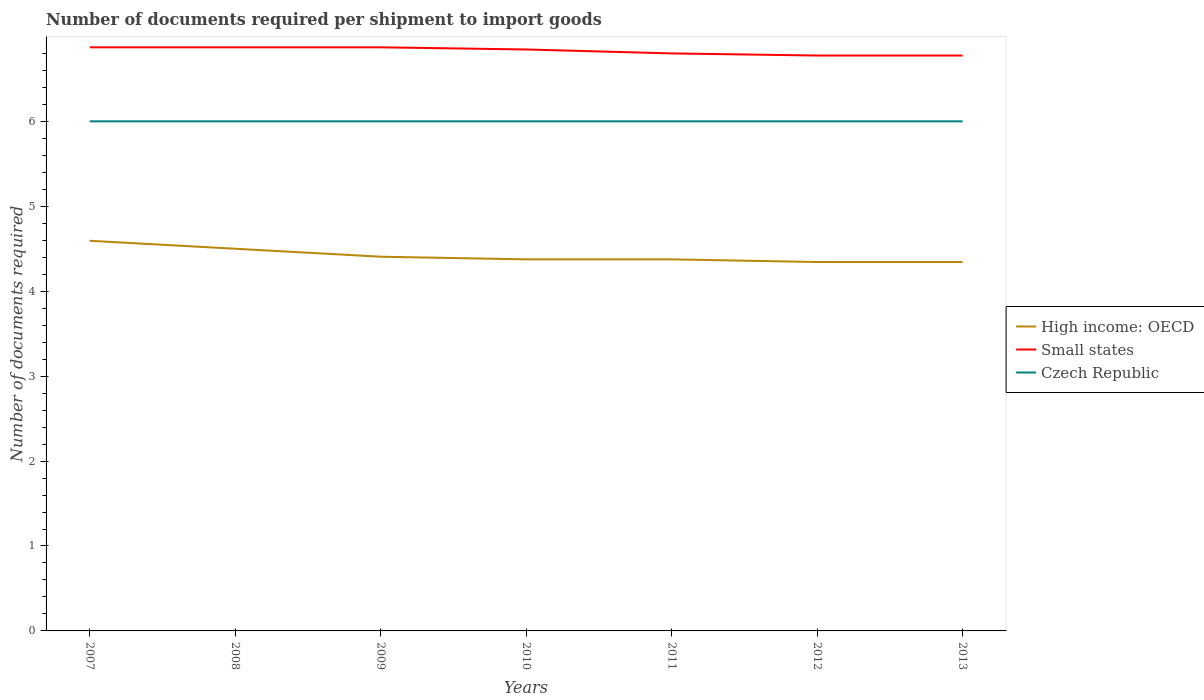How many different coloured lines are there?
Your answer should be very brief. 3. Does the line corresponding to High income: OECD intersect with the line corresponding to Czech Republic?
Provide a succinct answer. No. Is the number of lines equal to the number of legend labels?
Give a very brief answer. Yes. Across all years, what is the maximum number of documents required per shipment to import goods in Small states?
Offer a very short reply. 6.78. In which year was the number of documents required per shipment to import goods in Czech Republic maximum?
Keep it short and to the point. 2007. What is the total number of documents required per shipment to import goods in High income: OECD in the graph?
Ensure brevity in your answer.  0.06. Is the number of documents required per shipment to import goods in Small states strictly greater than the number of documents required per shipment to import goods in Czech Republic over the years?
Give a very brief answer. No. How many lines are there?
Make the answer very short. 3. How many years are there in the graph?
Offer a terse response. 7. What is the difference between two consecutive major ticks on the Y-axis?
Make the answer very short. 1. Are the values on the major ticks of Y-axis written in scientific E-notation?
Offer a very short reply. No. Where does the legend appear in the graph?
Your answer should be very brief. Center right. What is the title of the graph?
Keep it short and to the point. Number of documents required per shipment to import goods. Does "Kazakhstan" appear as one of the legend labels in the graph?
Your answer should be compact. No. What is the label or title of the Y-axis?
Keep it short and to the point. Number of documents required. What is the Number of documents required of High income: OECD in 2007?
Your answer should be compact. 4.59. What is the Number of documents required of Small states in 2007?
Ensure brevity in your answer.  6.87. What is the Number of documents required of High income: OECD in 2008?
Offer a terse response. 4.5. What is the Number of documents required of Small states in 2008?
Make the answer very short. 6.87. What is the Number of documents required of Czech Republic in 2008?
Provide a succinct answer. 6. What is the Number of documents required of High income: OECD in 2009?
Offer a terse response. 4.41. What is the Number of documents required in Small states in 2009?
Keep it short and to the point. 6.87. What is the Number of documents required in High income: OECD in 2010?
Your response must be concise. 4.38. What is the Number of documents required in Small states in 2010?
Make the answer very short. 6.85. What is the Number of documents required of Czech Republic in 2010?
Provide a short and direct response. 6. What is the Number of documents required in High income: OECD in 2011?
Provide a short and direct response. 4.38. What is the Number of documents required of Small states in 2011?
Offer a terse response. 6.8. What is the Number of documents required in High income: OECD in 2012?
Keep it short and to the point. 4.34. What is the Number of documents required of Small states in 2012?
Provide a succinct answer. 6.78. What is the Number of documents required in Czech Republic in 2012?
Offer a terse response. 6. What is the Number of documents required in High income: OECD in 2013?
Your answer should be compact. 4.34. What is the Number of documents required in Small states in 2013?
Offer a very short reply. 6.78. Across all years, what is the maximum Number of documents required in High income: OECD?
Keep it short and to the point. 4.59. Across all years, what is the maximum Number of documents required in Small states?
Provide a succinct answer. 6.87. Across all years, what is the minimum Number of documents required in High income: OECD?
Provide a succinct answer. 4.34. Across all years, what is the minimum Number of documents required of Small states?
Provide a succinct answer. 6.78. What is the total Number of documents required in High income: OECD in the graph?
Give a very brief answer. 30.94. What is the total Number of documents required in Small states in the graph?
Offer a terse response. 47.81. What is the total Number of documents required of Czech Republic in the graph?
Ensure brevity in your answer.  42. What is the difference between the Number of documents required of High income: OECD in 2007 and that in 2008?
Your response must be concise. 0.09. What is the difference between the Number of documents required in Small states in 2007 and that in 2008?
Your response must be concise. 0. What is the difference between the Number of documents required of Czech Republic in 2007 and that in 2008?
Offer a terse response. 0. What is the difference between the Number of documents required in High income: OECD in 2007 and that in 2009?
Give a very brief answer. 0.19. What is the difference between the Number of documents required in High income: OECD in 2007 and that in 2010?
Give a very brief answer. 0.22. What is the difference between the Number of documents required of Small states in 2007 and that in 2010?
Offer a terse response. 0.03. What is the difference between the Number of documents required in Czech Republic in 2007 and that in 2010?
Keep it short and to the point. 0. What is the difference between the Number of documents required of High income: OECD in 2007 and that in 2011?
Make the answer very short. 0.22. What is the difference between the Number of documents required of Small states in 2007 and that in 2011?
Your response must be concise. 0.07. What is the difference between the Number of documents required in Small states in 2007 and that in 2012?
Keep it short and to the point. 0.1. What is the difference between the Number of documents required in Czech Republic in 2007 and that in 2012?
Provide a succinct answer. 0. What is the difference between the Number of documents required of Small states in 2007 and that in 2013?
Ensure brevity in your answer.  0.1. What is the difference between the Number of documents required of Czech Republic in 2007 and that in 2013?
Your answer should be compact. 0. What is the difference between the Number of documents required in High income: OECD in 2008 and that in 2009?
Provide a succinct answer. 0.09. What is the difference between the Number of documents required in Small states in 2008 and that in 2009?
Your answer should be very brief. 0. What is the difference between the Number of documents required in Czech Republic in 2008 and that in 2009?
Your answer should be compact. 0. What is the difference between the Number of documents required in Small states in 2008 and that in 2010?
Provide a succinct answer. 0.03. What is the difference between the Number of documents required in Czech Republic in 2008 and that in 2010?
Your response must be concise. 0. What is the difference between the Number of documents required in Small states in 2008 and that in 2011?
Provide a short and direct response. 0.07. What is the difference between the Number of documents required in Czech Republic in 2008 and that in 2011?
Provide a short and direct response. 0. What is the difference between the Number of documents required of High income: OECD in 2008 and that in 2012?
Ensure brevity in your answer.  0.16. What is the difference between the Number of documents required in Small states in 2008 and that in 2012?
Offer a very short reply. 0.1. What is the difference between the Number of documents required of Czech Republic in 2008 and that in 2012?
Your answer should be compact. 0. What is the difference between the Number of documents required in High income: OECD in 2008 and that in 2013?
Provide a short and direct response. 0.16. What is the difference between the Number of documents required of Small states in 2008 and that in 2013?
Your response must be concise. 0.1. What is the difference between the Number of documents required of High income: OECD in 2009 and that in 2010?
Your response must be concise. 0.03. What is the difference between the Number of documents required of Small states in 2009 and that in 2010?
Your response must be concise. 0.03. What is the difference between the Number of documents required of Czech Republic in 2009 and that in 2010?
Give a very brief answer. 0. What is the difference between the Number of documents required of High income: OECD in 2009 and that in 2011?
Offer a terse response. 0.03. What is the difference between the Number of documents required of Small states in 2009 and that in 2011?
Make the answer very short. 0.07. What is the difference between the Number of documents required of High income: OECD in 2009 and that in 2012?
Give a very brief answer. 0.06. What is the difference between the Number of documents required in Small states in 2009 and that in 2012?
Offer a very short reply. 0.1. What is the difference between the Number of documents required of Czech Republic in 2009 and that in 2012?
Offer a very short reply. 0. What is the difference between the Number of documents required in High income: OECD in 2009 and that in 2013?
Your response must be concise. 0.06. What is the difference between the Number of documents required of Small states in 2009 and that in 2013?
Make the answer very short. 0.1. What is the difference between the Number of documents required of Czech Republic in 2009 and that in 2013?
Your answer should be very brief. 0. What is the difference between the Number of documents required in Small states in 2010 and that in 2011?
Offer a terse response. 0.05. What is the difference between the Number of documents required of High income: OECD in 2010 and that in 2012?
Ensure brevity in your answer.  0.03. What is the difference between the Number of documents required in Small states in 2010 and that in 2012?
Ensure brevity in your answer.  0.07. What is the difference between the Number of documents required of High income: OECD in 2010 and that in 2013?
Offer a terse response. 0.03. What is the difference between the Number of documents required in Small states in 2010 and that in 2013?
Make the answer very short. 0.07. What is the difference between the Number of documents required in Czech Republic in 2010 and that in 2013?
Your answer should be compact. 0. What is the difference between the Number of documents required in High income: OECD in 2011 and that in 2012?
Your response must be concise. 0.03. What is the difference between the Number of documents required of Small states in 2011 and that in 2012?
Keep it short and to the point. 0.03. What is the difference between the Number of documents required of Czech Republic in 2011 and that in 2012?
Keep it short and to the point. 0. What is the difference between the Number of documents required in High income: OECD in 2011 and that in 2013?
Your answer should be very brief. 0.03. What is the difference between the Number of documents required of Small states in 2011 and that in 2013?
Provide a short and direct response. 0.03. What is the difference between the Number of documents required of Czech Republic in 2011 and that in 2013?
Your answer should be compact. 0. What is the difference between the Number of documents required in High income: OECD in 2012 and that in 2013?
Your answer should be very brief. 0. What is the difference between the Number of documents required of Small states in 2012 and that in 2013?
Your response must be concise. 0. What is the difference between the Number of documents required of High income: OECD in 2007 and the Number of documents required of Small states in 2008?
Your answer should be compact. -2.28. What is the difference between the Number of documents required in High income: OECD in 2007 and the Number of documents required in Czech Republic in 2008?
Give a very brief answer. -1.41. What is the difference between the Number of documents required in Small states in 2007 and the Number of documents required in Czech Republic in 2008?
Keep it short and to the point. 0.87. What is the difference between the Number of documents required of High income: OECD in 2007 and the Number of documents required of Small states in 2009?
Offer a terse response. -2.28. What is the difference between the Number of documents required of High income: OECD in 2007 and the Number of documents required of Czech Republic in 2009?
Offer a very short reply. -1.41. What is the difference between the Number of documents required in Small states in 2007 and the Number of documents required in Czech Republic in 2009?
Provide a succinct answer. 0.87. What is the difference between the Number of documents required in High income: OECD in 2007 and the Number of documents required in Small states in 2010?
Provide a succinct answer. -2.25. What is the difference between the Number of documents required of High income: OECD in 2007 and the Number of documents required of Czech Republic in 2010?
Give a very brief answer. -1.41. What is the difference between the Number of documents required in Small states in 2007 and the Number of documents required in Czech Republic in 2010?
Your answer should be very brief. 0.87. What is the difference between the Number of documents required in High income: OECD in 2007 and the Number of documents required in Small states in 2011?
Your response must be concise. -2.21. What is the difference between the Number of documents required in High income: OECD in 2007 and the Number of documents required in Czech Republic in 2011?
Provide a succinct answer. -1.41. What is the difference between the Number of documents required of Small states in 2007 and the Number of documents required of Czech Republic in 2011?
Offer a very short reply. 0.87. What is the difference between the Number of documents required of High income: OECD in 2007 and the Number of documents required of Small states in 2012?
Ensure brevity in your answer.  -2.18. What is the difference between the Number of documents required in High income: OECD in 2007 and the Number of documents required in Czech Republic in 2012?
Provide a succinct answer. -1.41. What is the difference between the Number of documents required in Small states in 2007 and the Number of documents required in Czech Republic in 2012?
Keep it short and to the point. 0.87. What is the difference between the Number of documents required in High income: OECD in 2007 and the Number of documents required in Small states in 2013?
Keep it short and to the point. -2.18. What is the difference between the Number of documents required in High income: OECD in 2007 and the Number of documents required in Czech Republic in 2013?
Your answer should be compact. -1.41. What is the difference between the Number of documents required of Small states in 2007 and the Number of documents required of Czech Republic in 2013?
Offer a very short reply. 0.87. What is the difference between the Number of documents required of High income: OECD in 2008 and the Number of documents required of Small states in 2009?
Provide a short and direct response. -2.37. What is the difference between the Number of documents required of High income: OECD in 2008 and the Number of documents required of Czech Republic in 2009?
Make the answer very short. -1.5. What is the difference between the Number of documents required in Small states in 2008 and the Number of documents required in Czech Republic in 2009?
Provide a short and direct response. 0.87. What is the difference between the Number of documents required in High income: OECD in 2008 and the Number of documents required in Small states in 2010?
Provide a succinct answer. -2.35. What is the difference between the Number of documents required of High income: OECD in 2008 and the Number of documents required of Czech Republic in 2010?
Your answer should be compact. -1.5. What is the difference between the Number of documents required of Small states in 2008 and the Number of documents required of Czech Republic in 2010?
Offer a terse response. 0.87. What is the difference between the Number of documents required in High income: OECD in 2008 and the Number of documents required in Small states in 2011?
Offer a very short reply. -2.3. What is the difference between the Number of documents required in High income: OECD in 2008 and the Number of documents required in Czech Republic in 2011?
Offer a terse response. -1.5. What is the difference between the Number of documents required in Small states in 2008 and the Number of documents required in Czech Republic in 2011?
Keep it short and to the point. 0.87. What is the difference between the Number of documents required in High income: OECD in 2008 and the Number of documents required in Small states in 2012?
Give a very brief answer. -2.27. What is the difference between the Number of documents required of Small states in 2008 and the Number of documents required of Czech Republic in 2012?
Keep it short and to the point. 0.87. What is the difference between the Number of documents required of High income: OECD in 2008 and the Number of documents required of Small states in 2013?
Give a very brief answer. -2.27. What is the difference between the Number of documents required in Small states in 2008 and the Number of documents required in Czech Republic in 2013?
Offer a terse response. 0.87. What is the difference between the Number of documents required in High income: OECD in 2009 and the Number of documents required in Small states in 2010?
Provide a succinct answer. -2.44. What is the difference between the Number of documents required in High income: OECD in 2009 and the Number of documents required in Czech Republic in 2010?
Offer a terse response. -1.59. What is the difference between the Number of documents required of Small states in 2009 and the Number of documents required of Czech Republic in 2010?
Offer a terse response. 0.87. What is the difference between the Number of documents required in High income: OECD in 2009 and the Number of documents required in Small states in 2011?
Offer a terse response. -2.39. What is the difference between the Number of documents required in High income: OECD in 2009 and the Number of documents required in Czech Republic in 2011?
Keep it short and to the point. -1.59. What is the difference between the Number of documents required of Small states in 2009 and the Number of documents required of Czech Republic in 2011?
Make the answer very short. 0.87. What is the difference between the Number of documents required in High income: OECD in 2009 and the Number of documents required in Small states in 2012?
Offer a terse response. -2.37. What is the difference between the Number of documents required in High income: OECD in 2009 and the Number of documents required in Czech Republic in 2012?
Provide a succinct answer. -1.59. What is the difference between the Number of documents required of Small states in 2009 and the Number of documents required of Czech Republic in 2012?
Your response must be concise. 0.87. What is the difference between the Number of documents required of High income: OECD in 2009 and the Number of documents required of Small states in 2013?
Your answer should be compact. -2.37. What is the difference between the Number of documents required in High income: OECD in 2009 and the Number of documents required in Czech Republic in 2013?
Your answer should be compact. -1.59. What is the difference between the Number of documents required in Small states in 2009 and the Number of documents required in Czech Republic in 2013?
Your answer should be very brief. 0.87. What is the difference between the Number of documents required of High income: OECD in 2010 and the Number of documents required of Small states in 2011?
Keep it short and to the point. -2.42. What is the difference between the Number of documents required of High income: OECD in 2010 and the Number of documents required of Czech Republic in 2011?
Make the answer very short. -1.62. What is the difference between the Number of documents required of Small states in 2010 and the Number of documents required of Czech Republic in 2011?
Offer a very short reply. 0.85. What is the difference between the Number of documents required in High income: OECD in 2010 and the Number of documents required in Small states in 2012?
Your answer should be very brief. -2.4. What is the difference between the Number of documents required of High income: OECD in 2010 and the Number of documents required of Czech Republic in 2012?
Your response must be concise. -1.62. What is the difference between the Number of documents required in Small states in 2010 and the Number of documents required in Czech Republic in 2012?
Offer a terse response. 0.85. What is the difference between the Number of documents required of High income: OECD in 2010 and the Number of documents required of Small states in 2013?
Your answer should be compact. -2.4. What is the difference between the Number of documents required of High income: OECD in 2010 and the Number of documents required of Czech Republic in 2013?
Offer a very short reply. -1.62. What is the difference between the Number of documents required in Small states in 2010 and the Number of documents required in Czech Republic in 2013?
Your answer should be compact. 0.85. What is the difference between the Number of documents required in High income: OECD in 2011 and the Number of documents required in Small states in 2012?
Provide a short and direct response. -2.4. What is the difference between the Number of documents required in High income: OECD in 2011 and the Number of documents required in Czech Republic in 2012?
Make the answer very short. -1.62. What is the difference between the Number of documents required of High income: OECD in 2011 and the Number of documents required of Czech Republic in 2013?
Offer a terse response. -1.62. What is the difference between the Number of documents required of Small states in 2011 and the Number of documents required of Czech Republic in 2013?
Provide a succinct answer. 0.8. What is the difference between the Number of documents required of High income: OECD in 2012 and the Number of documents required of Small states in 2013?
Provide a short and direct response. -2.43. What is the difference between the Number of documents required of High income: OECD in 2012 and the Number of documents required of Czech Republic in 2013?
Provide a short and direct response. -1.66. What is the difference between the Number of documents required in Small states in 2012 and the Number of documents required in Czech Republic in 2013?
Provide a succinct answer. 0.78. What is the average Number of documents required of High income: OECD per year?
Your answer should be compact. 4.42. What is the average Number of documents required in Small states per year?
Keep it short and to the point. 6.83. In the year 2007, what is the difference between the Number of documents required in High income: OECD and Number of documents required in Small states?
Keep it short and to the point. -2.28. In the year 2007, what is the difference between the Number of documents required of High income: OECD and Number of documents required of Czech Republic?
Make the answer very short. -1.41. In the year 2007, what is the difference between the Number of documents required in Small states and Number of documents required in Czech Republic?
Ensure brevity in your answer.  0.87. In the year 2008, what is the difference between the Number of documents required in High income: OECD and Number of documents required in Small states?
Your response must be concise. -2.37. In the year 2008, what is the difference between the Number of documents required in Small states and Number of documents required in Czech Republic?
Ensure brevity in your answer.  0.87. In the year 2009, what is the difference between the Number of documents required in High income: OECD and Number of documents required in Small states?
Keep it short and to the point. -2.47. In the year 2009, what is the difference between the Number of documents required of High income: OECD and Number of documents required of Czech Republic?
Provide a short and direct response. -1.59. In the year 2009, what is the difference between the Number of documents required of Small states and Number of documents required of Czech Republic?
Keep it short and to the point. 0.87. In the year 2010, what is the difference between the Number of documents required in High income: OECD and Number of documents required in Small states?
Provide a short and direct response. -2.47. In the year 2010, what is the difference between the Number of documents required of High income: OECD and Number of documents required of Czech Republic?
Provide a short and direct response. -1.62. In the year 2010, what is the difference between the Number of documents required of Small states and Number of documents required of Czech Republic?
Give a very brief answer. 0.85. In the year 2011, what is the difference between the Number of documents required in High income: OECD and Number of documents required in Small states?
Make the answer very short. -2.42. In the year 2011, what is the difference between the Number of documents required of High income: OECD and Number of documents required of Czech Republic?
Keep it short and to the point. -1.62. In the year 2012, what is the difference between the Number of documents required of High income: OECD and Number of documents required of Small states?
Make the answer very short. -2.43. In the year 2012, what is the difference between the Number of documents required in High income: OECD and Number of documents required in Czech Republic?
Keep it short and to the point. -1.66. In the year 2012, what is the difference between the Number of documents required of Small states and Number of documents required of Czech Republic?
Your answer should be very brief. 0.78. In the year 2013, what is the difference between the Number of documents required in High income: OECD and Number of documents required in Small states?
Provide a short and direct response. -2.43. In the year 2013, what is the difference between the Number of documents required in High income: OECD and Number of documents required in Czech Republic?
Give a very brief answer. -1.66. In the year 2013, what is the difference between the Number of documents required of Small states and Number of documents required of Czech Republic?
Your answer should be compact. 0.78. What is the ratio of the Number of documents required in High income: OECD in 2007 to that in 2008?
Provide a succinct answer. 1.02. What is the ratio of the Number of documents required of High income: OECD in 2007 to that in 2009?
Your response must be concise. 1.04. What is the ratio of the Number of documents required in Czech Republic in 2007 to that in 2009?
Your response must be concise. 1. What is the ratio of the Number of documents required in High income: OECD in 2007 to that in 2010?
Make the answer very short. 1.05. What is the ratio of the Number of documents required in High income: OECD in 2007 to that in 2011?
Make the answer very short. 1.05. What is the ratio of the Number of documents required in Small states in 2007 to that in 2011?
Provide a succinct answer. 1.01. What is the ratio of the Number of documents required in High income: OECD in 2007 to that in 2012?
Keep it short and to the point. 1.06. What is the ratio of the Number of documents required of Small states in 2007 to that in 2012?
Your response must be concise. 1.01. What is the ratio of the Number of documents required of Czech Republic in 2007 to that in 2012?
Your answer should be compact. 1. What is the ratio of the Number of documents required in High income: OECD in 2007 to that in 2013?
Provide a short and direct response. 1.06. What is the ratio of the Number of documents required in Small states in 2007 to that in 2013?
Provide a succinct answer. 1.01. What is the ratio of the Number of documents required in Czech Republic in 2007 to that in 2013?
Your answer should be compact. 1. What is the ratio of the Number of documents required in High income: OECD in 2008 to that in 2009?
Give a very brief answer. 1.02. What is the ratio of the Number of documents required in Small states in 2008 to that in 2009?
Your answer should be compact. 1. What is the ratio of the Number of documents required of Czech Republic in 2008 to that in 2009?
Make the answer very short. 1. What is the ratio of the Number of documents required in High income: OECD in 2008 to that in 2010?
Keep it short and to the point. 1.03. What is the ratio of the Number of documents required of Small states in 2008 to that in 2010?
Offer a terse response. 1. What is the ratio of the Number of documents required of High income: OECD in 2008 to that in 2011?
Provide a short and direct response. 1.03. What is the ratio of the Number of documents required of Small states in 2008 to that in 2011?
Keep it short and to the point. 1.01. What is the ratio of the Number of documents required of High income: OECD in 2008 to that in 2012?
Your answer should be very brief. 1.04. What is the ratio of the Number of documents required in Small states in 2008 to that in 2012?
Give a very brief answer. 1.01. What is the ratio of the Number of documents required in High income: OECD in 2008 to that in 2013?
Give a very brief answer. 1.04. What is the ratio of the Number of documents required of Small states in 2008 to that in 2013?
Your answer should be very brief. 1.01. What is the ratio of the Number of documents required of High income: OECD in 2009 to that in 2010?
Offer a terse response. 1.01. What is the ratio of the Number of documents required in Czech Republic in 2009 to that in 2010?
Provide a short and direct response. 1. What is the ratio of the Number of documents required of High income: OECD in 2009 to that in 2011?
Ensure brevity in your answer.  1.01. What is the ratio of the Number of documents required of Small states in 2009 to that in 2011?
Your response must be concise. 1.01. What is the ratio of the Number of documents required in High income: OECD in 2009 to that in 2012?
Your response must be concise. 1.01. What is the ratio of the Number of documents required of Small states in 2009 to that in 2012?
Your answer should be very brief. 1.01. What is the ratio of the Number of documents required of Czech Republic in 2009 to that in 2012?
Your answer should be very brief. 1. What is the ratio of the Number of documents required in High income: OECD in 2009 to that in 2013?
Make the answer very short. 1.01. What is the ratio of the Number of documents required in Small states in 2009 to that in 2013?
Your response must be concise. 1.01. What is the ratio of the Number of documents required of Czech Republic in 2009 to that in 2013?
Ensure brevity in your answer.  1. What is the ratio of the Number of documents required of Small states in 2010 to that in 2011?
Keep it short and to the point. 1.01. What is the ratio of the Number of documents required in Czech Republic in 2010 to that in 2011?
Give a very brief answer. 1. What is the ratio of the Number of documents required in High income: OECD in 2010 to that in 2012?
Keep it short and to the point. 1.01. What is the ratio of the Number of documents required of Small states in 2010 to that in 2012?
Provide a short and direct response. 1.01. What is the ratio of the Number of documents required in High income: OECD in 2010 to that in 2013?
Offer a very short reply. 1.01. What is the ratio of the Number of documents required of Small states in 2010 to that in 2013?
Ensure brevity in your answer.  1.01. What is the ratio of the Number of documents required in Czech Republic in 2010 to that in 2013?
Ensure brevity in your answer.  1. What is the ratio of the Number of documents required of High income: OECD in 2011 to that in 2012?
Give a very brief answer. 1.01. What is the ratio of the Number of documents required of High income: OECD in 2011 to that in 2013?
Give a very brief answer. 1.01. What is the ratio of the Number of documents required of Small states in 2011 to that in 2013?
Your answer should be very brief. 1. What is the ratio of the Number of documents required in High income: OECD in 2012 to that in 2013?
Make the answer very short. 1. What is the ratio of the Number of documents required of Small states in 2012 to that in 2013?
Offer a very short reply. 1. What is the ratio of the Number of documents required in Czech Republic in 2012 to that in 2013?
Ensure brevity in your answer.  1. What is the difference between the highest and the second highest Number of documents required in High income: OECD?
Ensure brevity in your answer.  0.09. What is the difference between the highest and the second highest Number of documents required in Small states?
Your answer should be compact. 0. What is the difference between the highest and the second highest Number of documents required of Czech Republic?
Your response must be concise. 0. What is the difference between the highest and the lowest Number of documents required in Small states?
Make the answer very short. 0.1. 